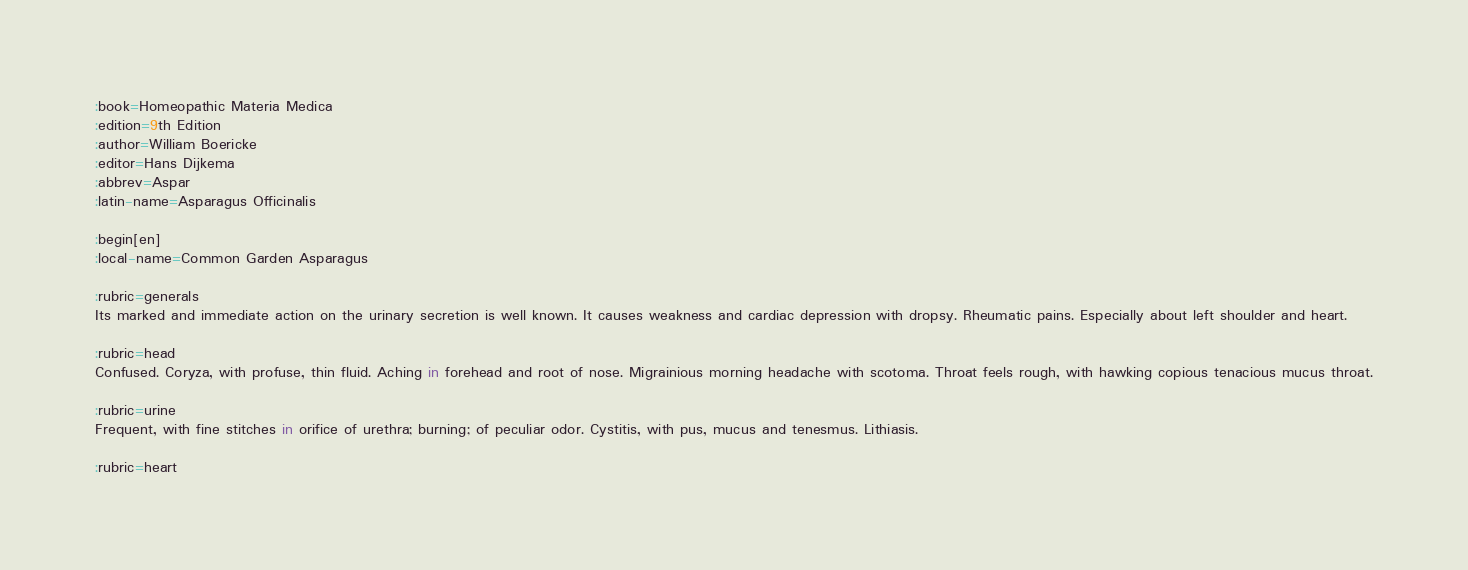Convert code to text. <code><loc_0><loc_0><loc_500><loc_500><_ObjectiveC_>:book=Homeopathic Materia Medica
:edition=9th Edition
:author=William Boericke
:editor=Hans Dijkema
:abbrev=Aspar
:latin-name=Asparagus Officinalis

:begin[en]
:local-name=Common Garden Asparagus

:rubric=generals
Its marked and immediate action on the urinary secretion is well known. It causes weakness and cardiac depression with dropsy. Rheumatic pains. Especially about left shoulder and heart.

:rubric=head
Confused. Coryza, with profuse, thin fluid. Aching in forehead and root of nose. Migrainious morning headache with scotoma. Throat feels rough, with hawking copious tenacious mucus throat.

:rubric=urine
Frequent, with fine stitches in orifice of urethra; burning; of peculiar odor. Cystitis, with pus, mucus and tenesmus. Lithiasis.

:rubric=heart</code> 